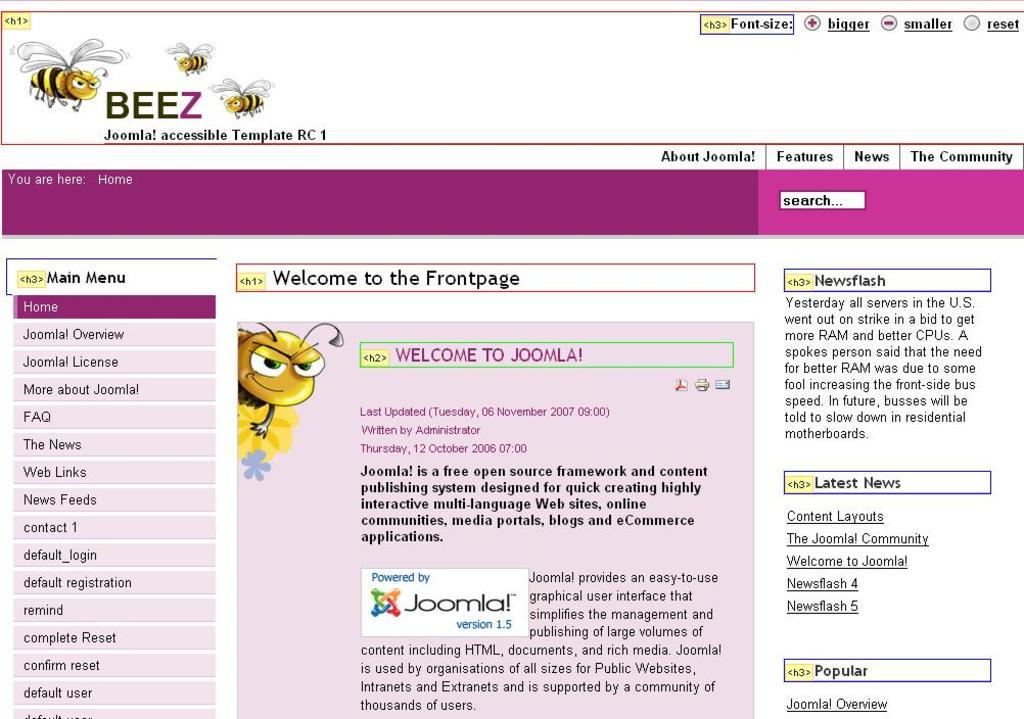What is the source of the image? The image is a screenshot of a computer screen. What type of character is present in the image? There is a cartoon-type honey bee in the image. What can be found in the middle of the image? There is some matter written in the middle of the image. What type of spade is being used by the honey bee in the image? There is no spade present in the image, and the honey bee is not using any tool. 